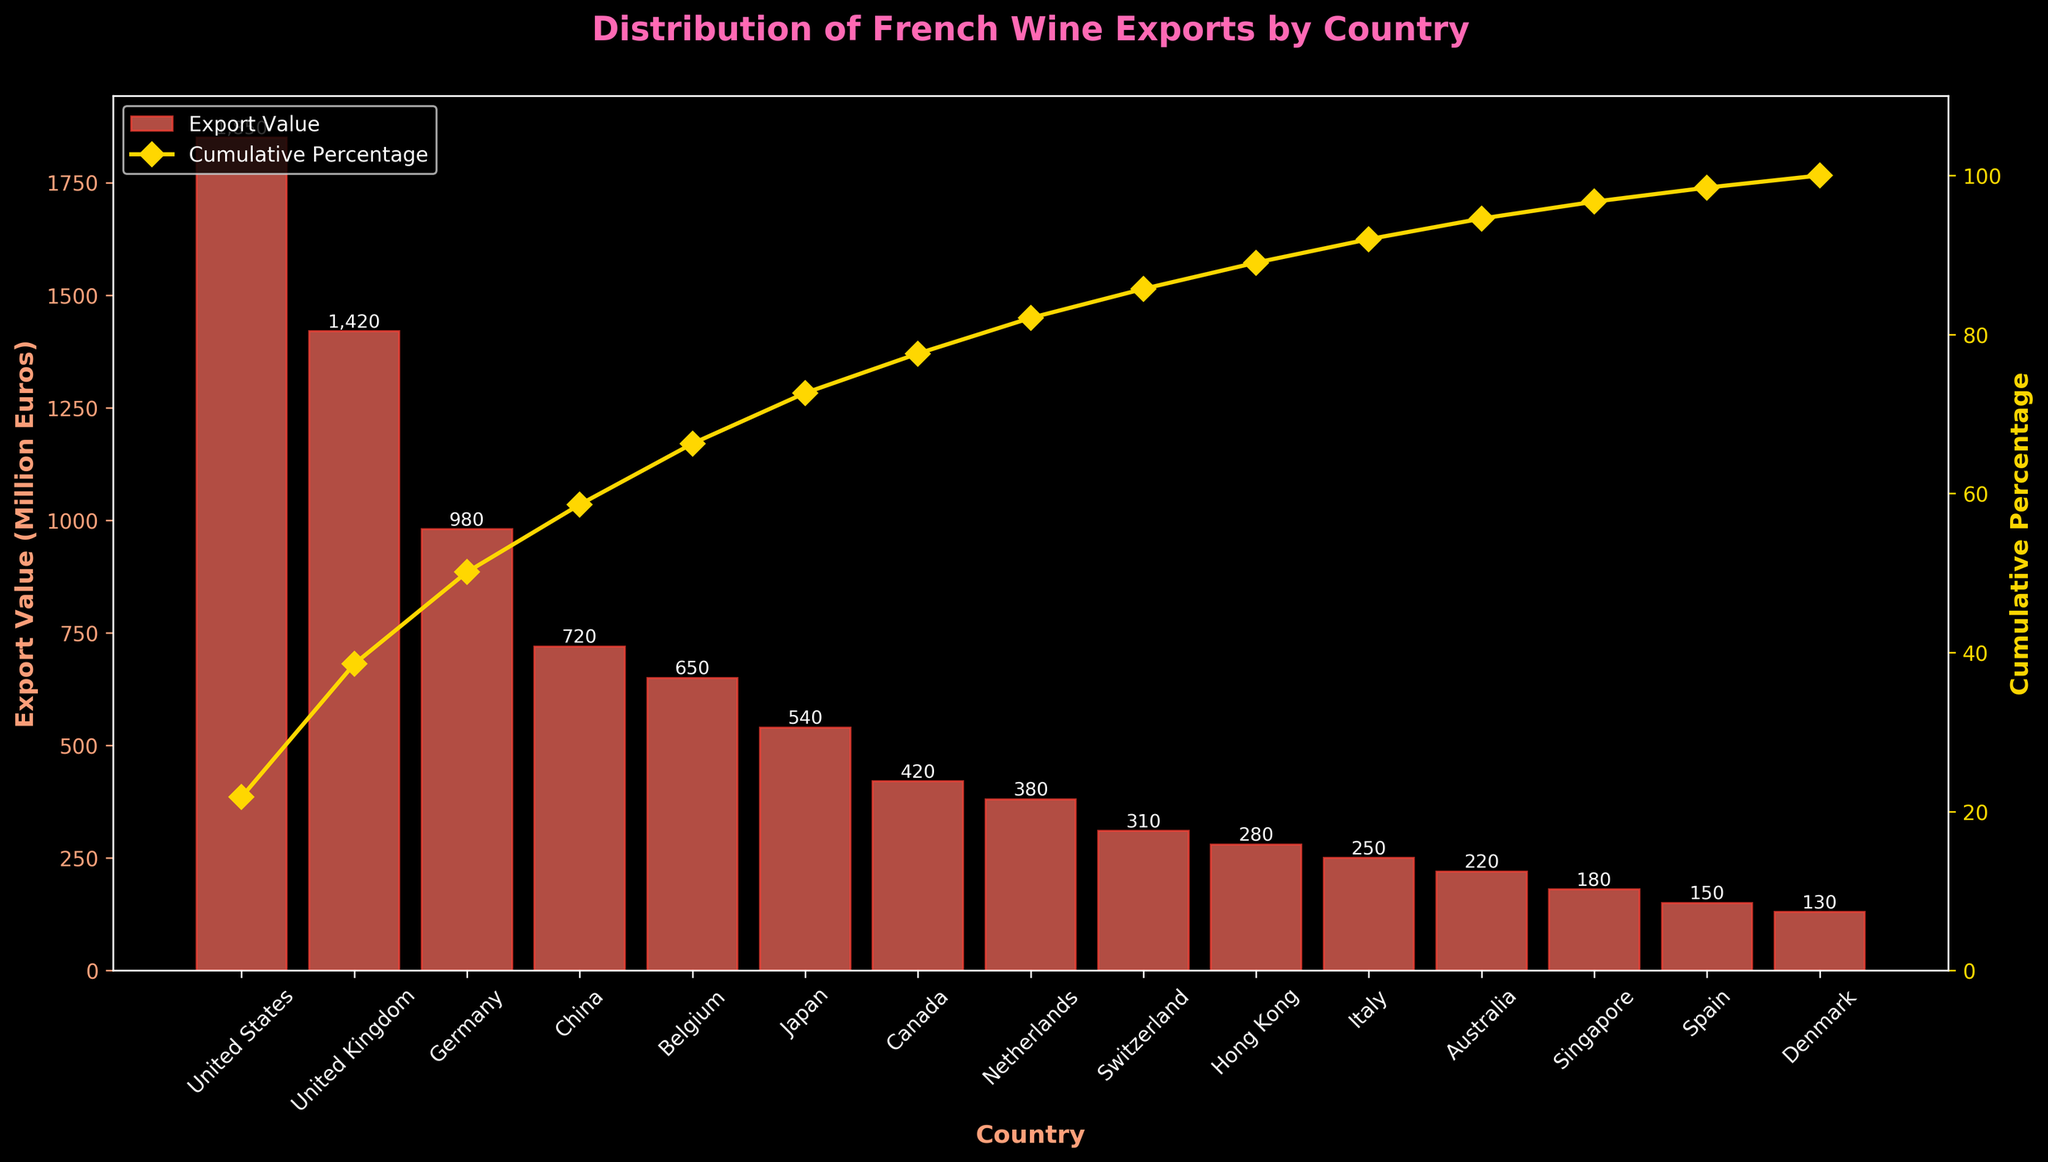What is the highest export value shown in the chart? The tallest bar in the chart represents the country with the highest export value. The label on this bar shows the value is 1850 million euros for the United States.
Answer: 1850 million euros Which country has the third highest export value? The chart's bars are sorted in descending order of export value. The third tallest bar represents Germany.
Answer: Germany What is the total export value for Belgium and Japan? The bars for Belgium and Japan show export values of 650 and 540 million euros, respectively. Adding these together gives 1190 million euros.
Answer: 1190 million euros Which country marks the 50% cumulative export value on the chart? The line plot denoting the cumulative percentage shows that after adding the values for United States, United Kingdom, and Germany, the cumulative value exceeds 50%. Checking these data points, Germany falls closest to the 50% mark.
Answer: Germany Is China or Japan responsible for a higher export value? The bars representing China and Japan show that China's export value (720 million euros) is higher than Japan's export value (540 million euros).
Answer: China What is the cumulative percentage after including exports to the United States, United Kingdom, and Germany? Adding export values of United States (1850), United Kingdom (1420), and Germany (980) gives a total of 4250 million euros. The cumulative percentage is calculated as (4250 / total export value) * 100.
Answer: 61.7% How much more does the United States export value contribute compared to Canada? The export value for United States (1850 million euros) minus the export value for Canada (420 million euros) gives the difference.
Answer: 1430 million euros Which country is last on the cumulative percentage line of the chart, and what is its export value? The final point on the line plot corresponds to the last country in the list. This aligns with Denmark, having an export value of 130 million euros.
Answer: Denmark, 130 million euros What is the median export value among all the listed countries? The median is the middle value when data points are arranged in order. With 15 countries, the eighth value is the median. Sorting the values gives: Netherlands with 380 million euros.
Answer: 380 million euros Which three countries together make up approximately the first third of the total export value? The total export value sums up to 8320 million euros. A third of this is ~2773 million euros. Adding United States (1850), United Kingdom (1420), and part of Germany’s (980) value covers this range.
Answer: United States, United Kingdom, and part of Germany 